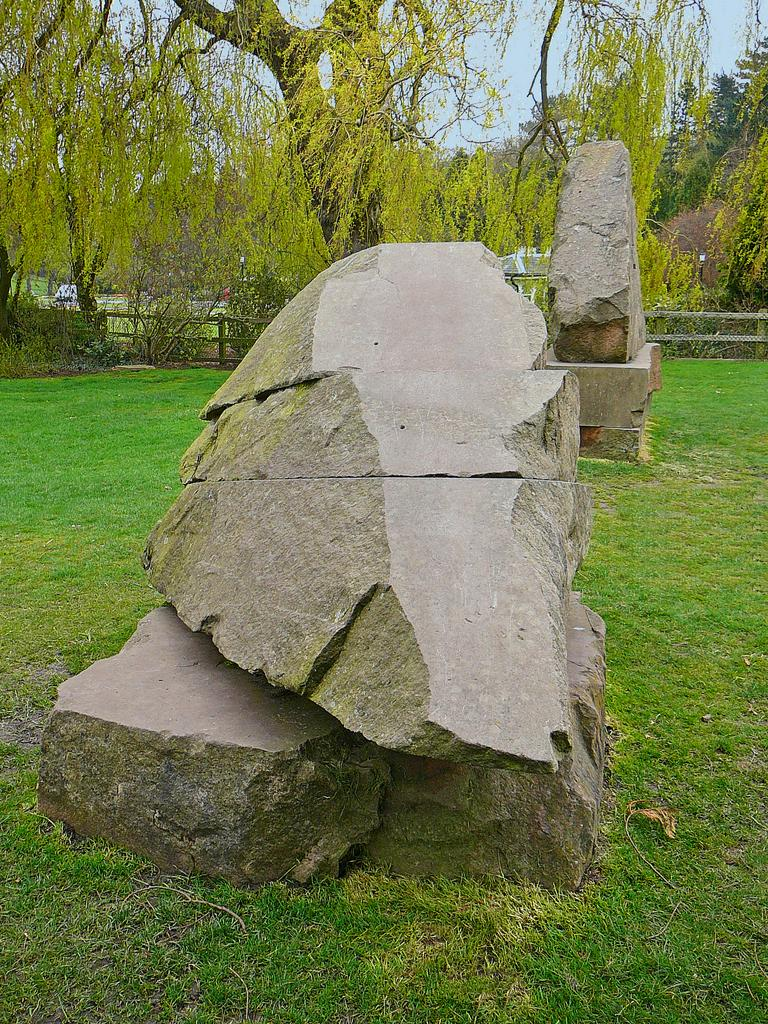What type of vegetation can be seen in the image? There is grass in the image. What other objects or features can be seen in the image? There are stones, a fence, and trees in the image. What is visible in the background of the image? The sky is visible in the background of the image. What type of pleasure does the grandmother experience while sitting on the division in the image? There is no grandmother or division present in the image. 